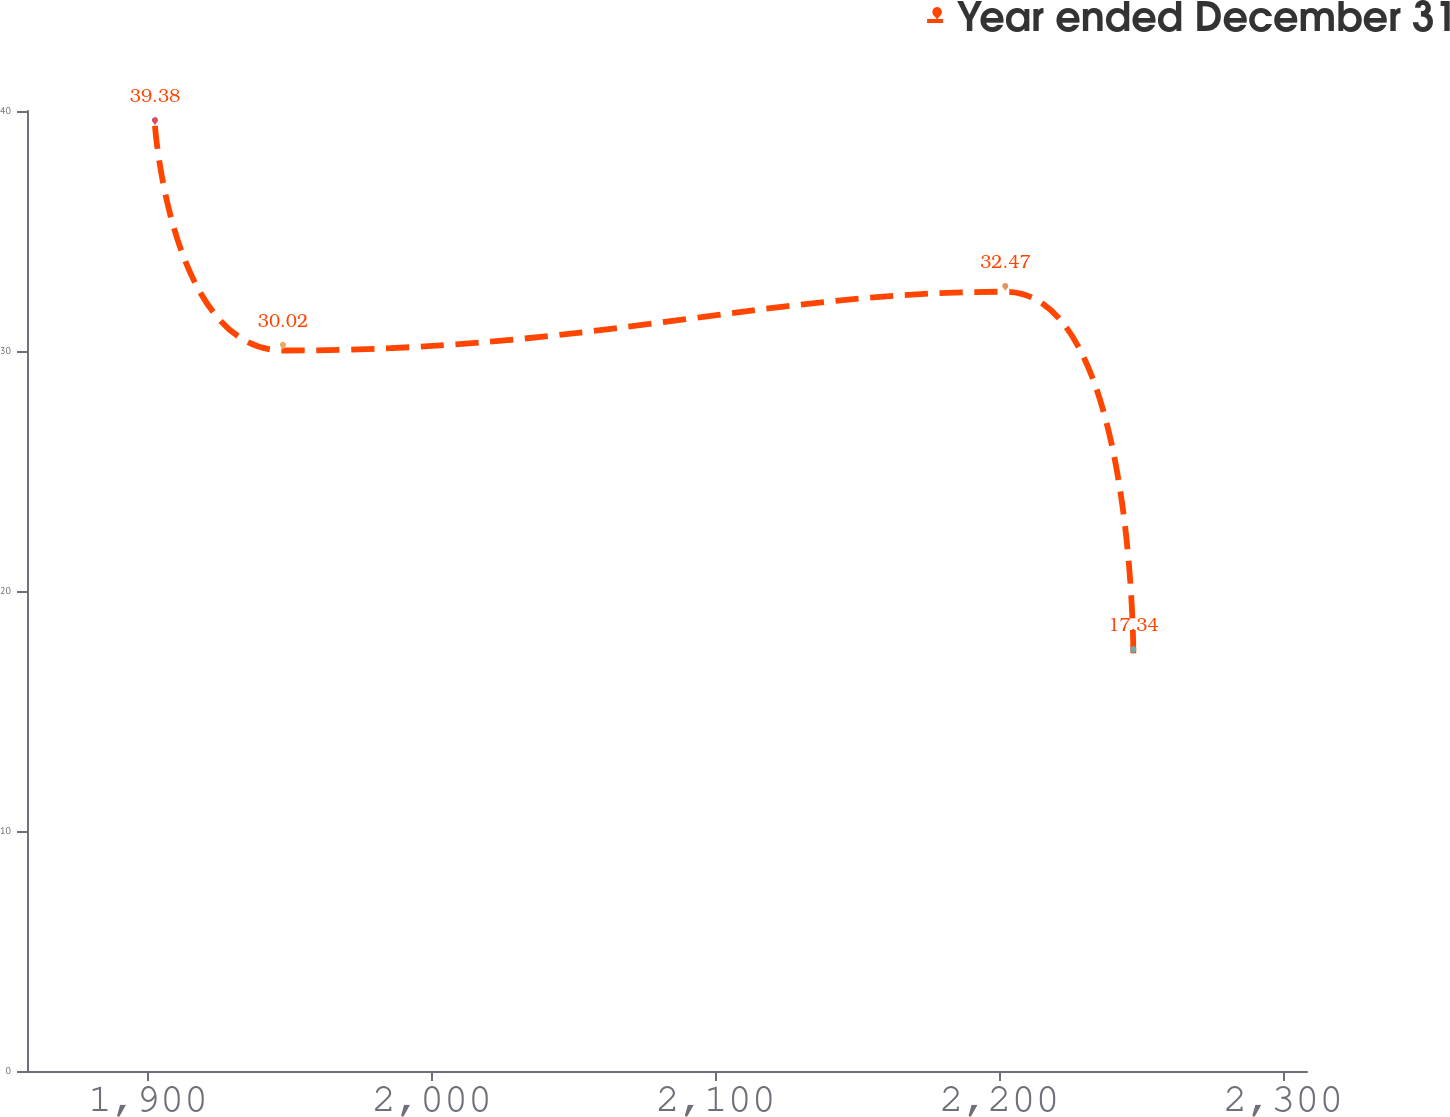<chart> <loc_0><loc_0><loc_500><loc_500><line_chart><ecel><fcel>Year ended December 31<nl><fcel>1902.43<fcel>39.38<nl><fcel>1947.53<fcel>30.02<nl><fcel>2202.07<fcel>32.47<nl><fcel>2247.17<fcel>17.34<nl><fcel>2353.46<fcel>14.89<nl></chart> 